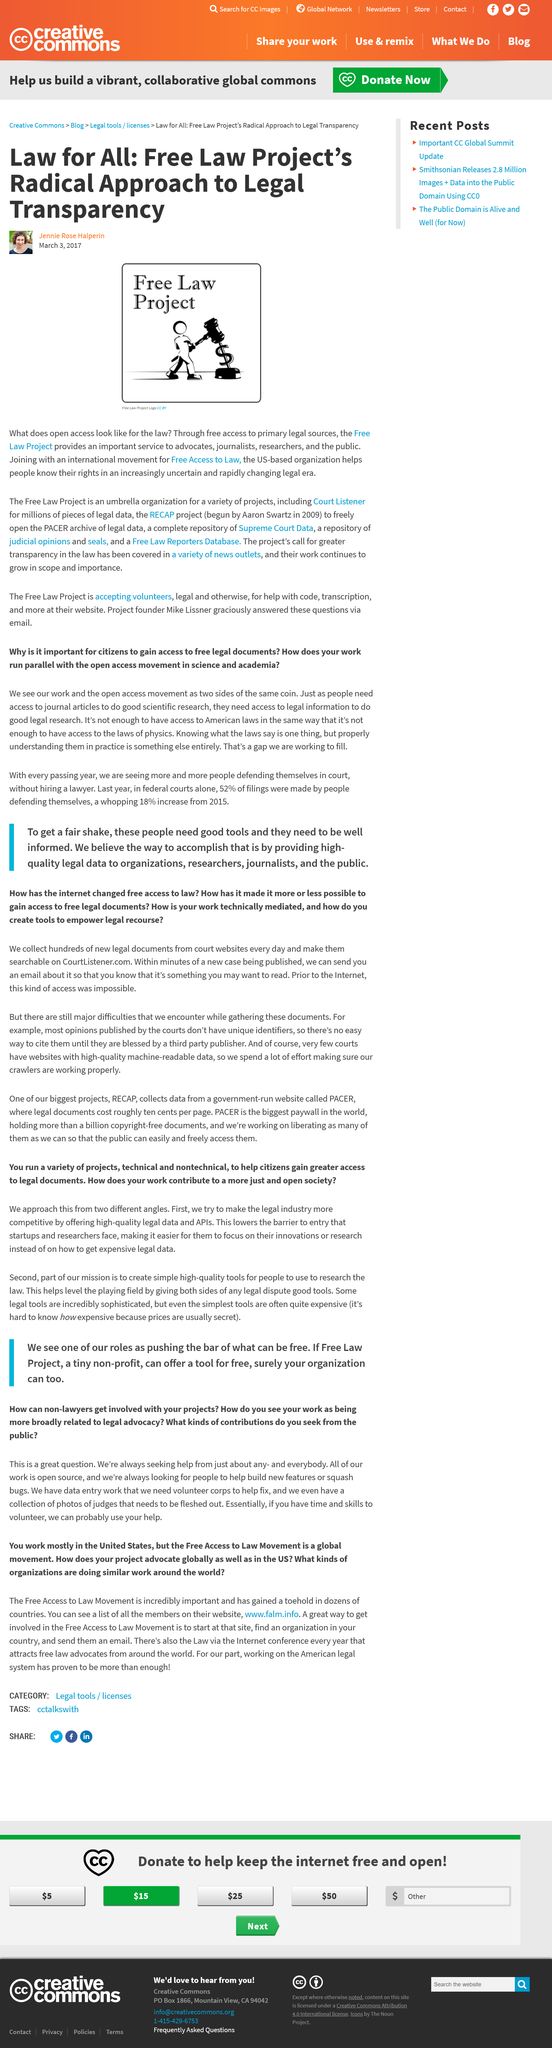Give some essential details in this illustration. The Free Law Project provides free access to primary legal sources, including court opinions and statutes, which are critical resources for understanding and engaging with the legal system. The organization is headquartered in the United States. The two-letter abbreviation for the country in which the Free Access to Law Movement does most of its work is "US. The international movement of Free Access to Law is mentioned in the article. The Free Access to Law Movement's middle part of their website address is a lowercase four-letter abbreviation, which is "falm. 